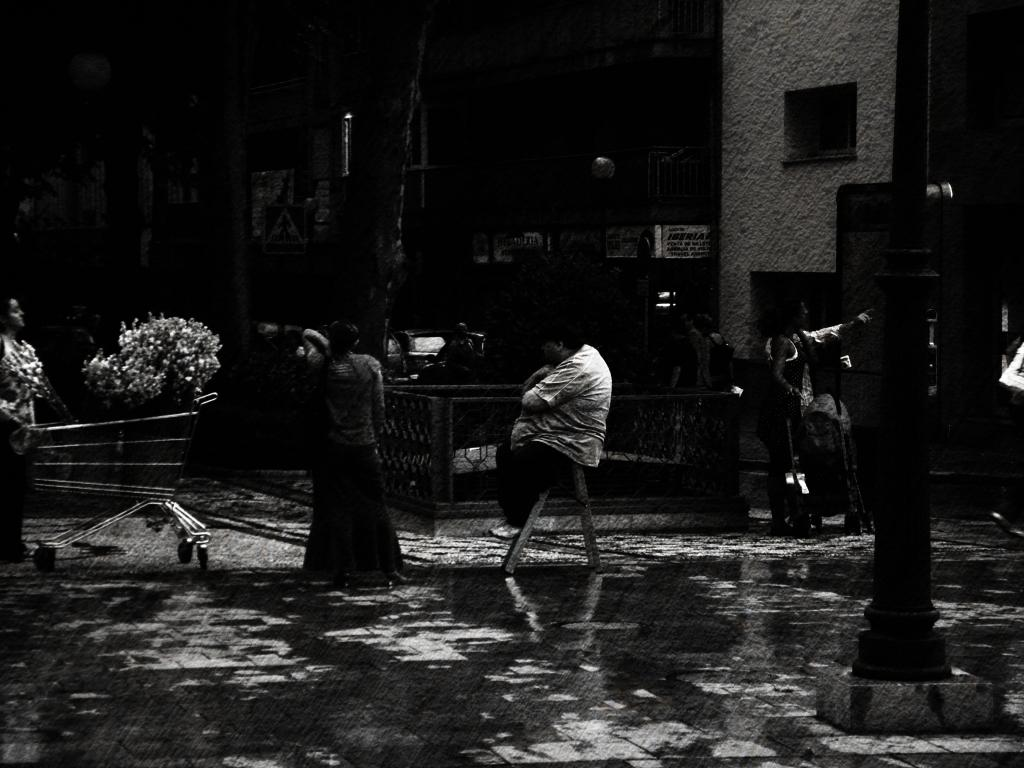What is the color scheme of the image? The image is black and white. How many people can be seen in the image? There are a few people in the image. What is visible beneath the people's feet? The ground is visible in the image. What structure is present in the image? There is a pole in the image. What mode of transportation is present in the image? A trolley is present in the image. What type of vegetation is visible in the image? There are plants in the image. What type of architectural feature is present in the image? There is a wall in the image. What other objects can be seen in the image? There are some objects in the image. What type of guide is leading the group of people in the image? There is no guide leading a group of people in the image. What is the distribution of the objects in the image? The distribution of objects cannot be determined from the image, as it is in black and white and does not provide a clear layout of the objects. 